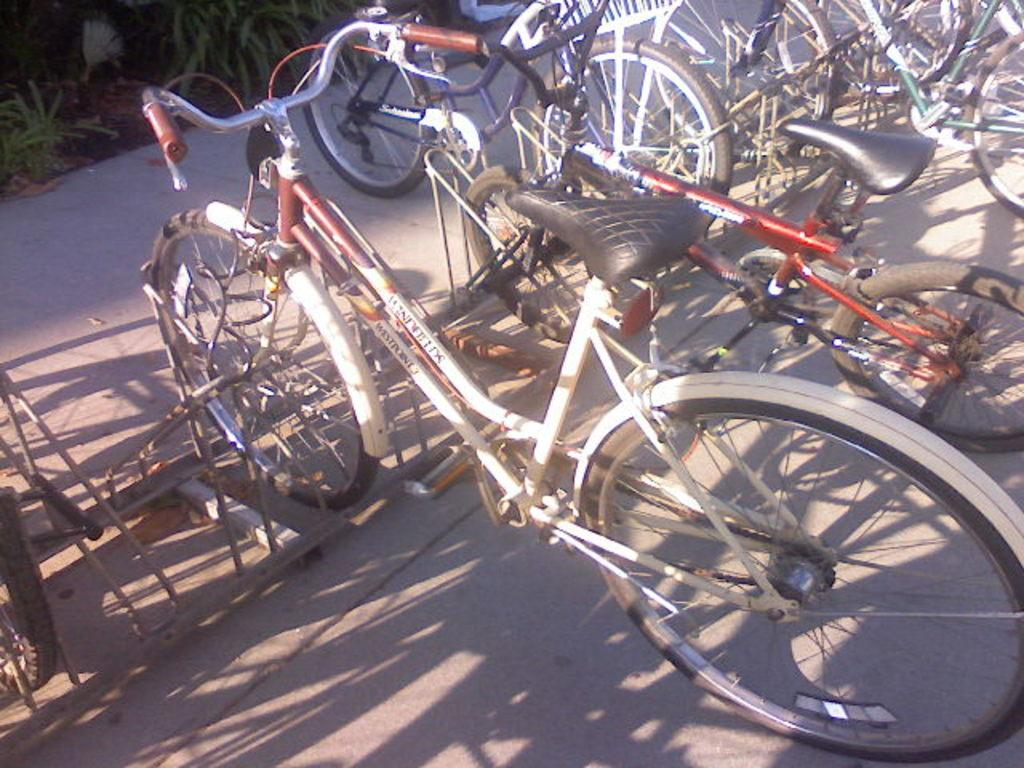What type of vehicles are parked on the road surface in the image? There are cycles parked on the road surface in the image. What can be seen behind the parked cycles? The cycles are parked in front of plants. What type of liquid is being dispensed from the hydrant in the image? There is no hydrant present in the image, so it is not possible to determine what type of liquid might be dispensed. 